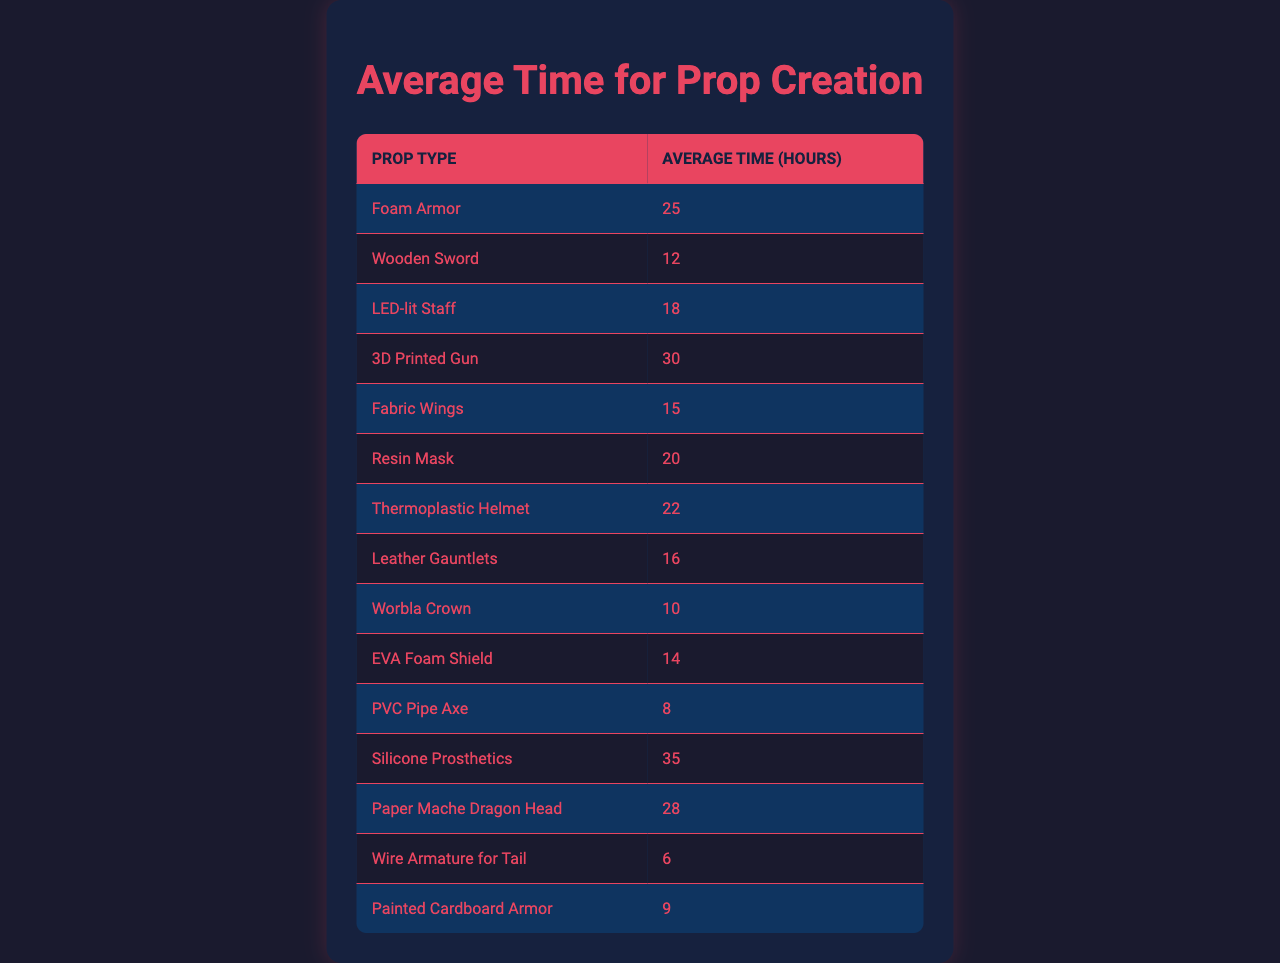What is the average time taken to create a Foam Armor prop? Looking at the table, the average time for creating a Foam Armor prop is directly listed under the relevant column, which shows 25 hours.
Answer: 25 hours Which prop takes the longest time to create? The table indicates that the Silicone Prosthetics prop has the highest average time at 35 hours, which is the maximum listed in the Average Time column.
Answer: Silicone Prosthetics What is the difference in average time between creating a 3D Printed Gun and a Wooden Sword? From the table, the average time for a 3D Printed Gun is 30 hours, while the Wooden Sword takes 12 hours. The difference is 30 - 12 = 18 hours.
Answer: 18 hours How many props have an average creation time of less than 15 hours? The props taking less than 15 hours are the PVC Pipe Axe (8 hours), Worbla Crown (10 hours), and Painted Cardboard Armor (9 hours). This is a total of 3 props.
Answer: 3 props Is it true that creating Fabric Wings takes less time than creating a Leather Gauntlet? According to the table, Fabric Wings take 15 hours, and Leather Gauntlets take 16 hours. Therefore, Fabric Wings take less time than Leather Gauntlets, making the statement true.
Answer: True What is the average time for all props listed in the table? To find the average, you first sum the average times: 25 + 12 + 18 + 30 + 15 + 20 + 22 + 16 + 10 + 14 + 8 + 35 + 28 + 6 + 9 =  339 hours. There are 15 props, so the average time is 339 / 15 = 22.6 hours.
Answer: 22.6 hours Which prop's creation time is closest to the average time calculated for all props? The average time is 22.6 hours; comparing this with the prop times, the Thermoplastic Helmet at 22 hours is the closest to this average.
Answer: Thermoplastic Helmet What types of props take longer than 20 hours to create? The props that take longer than 20 hours are the Foam Armor (25 hours), 3D Printed Gun (30 hours), Paper Mache Dragon Head (28 hours), Silicone Prosthetics (35 hours), and Thermoplastic Helmet (22 hours). Counting these, there are 5 such props.
Answer: 5 props Which is the least time-consuming prop to create based on the table? The least time-consuming prop can be found by looking for the smallest number in the Average Time column, which is the Wire Armature for Tail at 6 hours.
Answer: Wire Armature for Tail What is the combined average time of the two fastest props? The two fastest props are the Wire Armature for Tail (6 hours) and the PVC Pipe Axe (8 hours). Their combined average is (6 + 8) / 2 = 7 hours.
Answer: 7 hours Is the average time for creating a Resin Mask more than the average time for creating Fabric Wings? The average time for a Resin Mask is 20 hours and for Fabric Wings is 15 hours. Since 20 is greater than 15, the statement is true.
Answer: True 